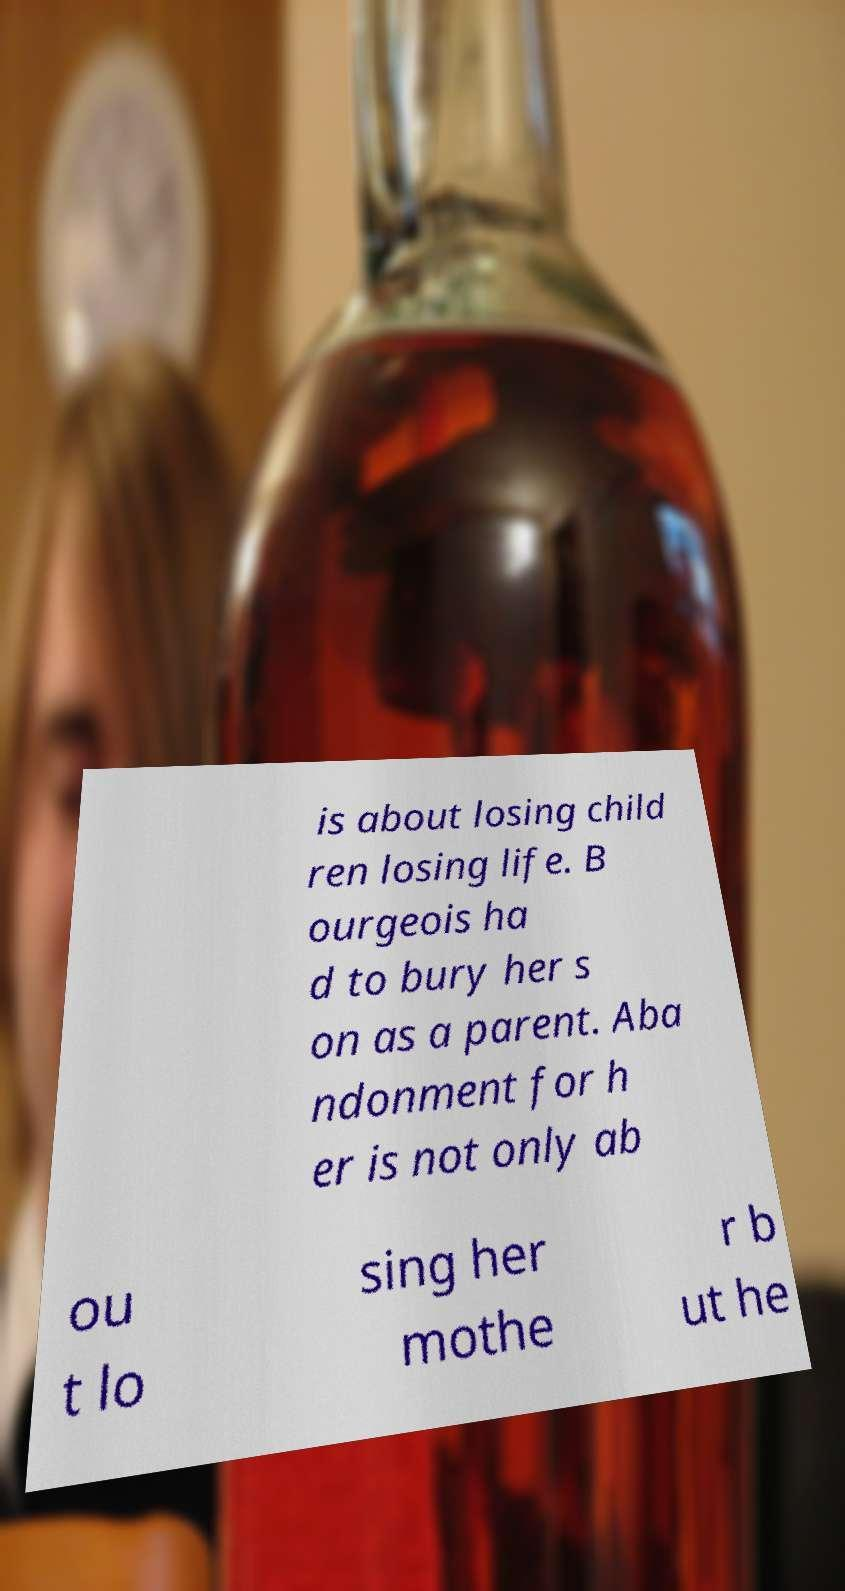Can you read and provide the text displayed in the image?This photo seems to have some interesting text. Can you extract and type it out for me? is about losing child ren losing life. B ourgeois ha d to bury her s on as a parent. Aba ndonment for h er is not only ab ou t lo sing her mothe r b ut he 